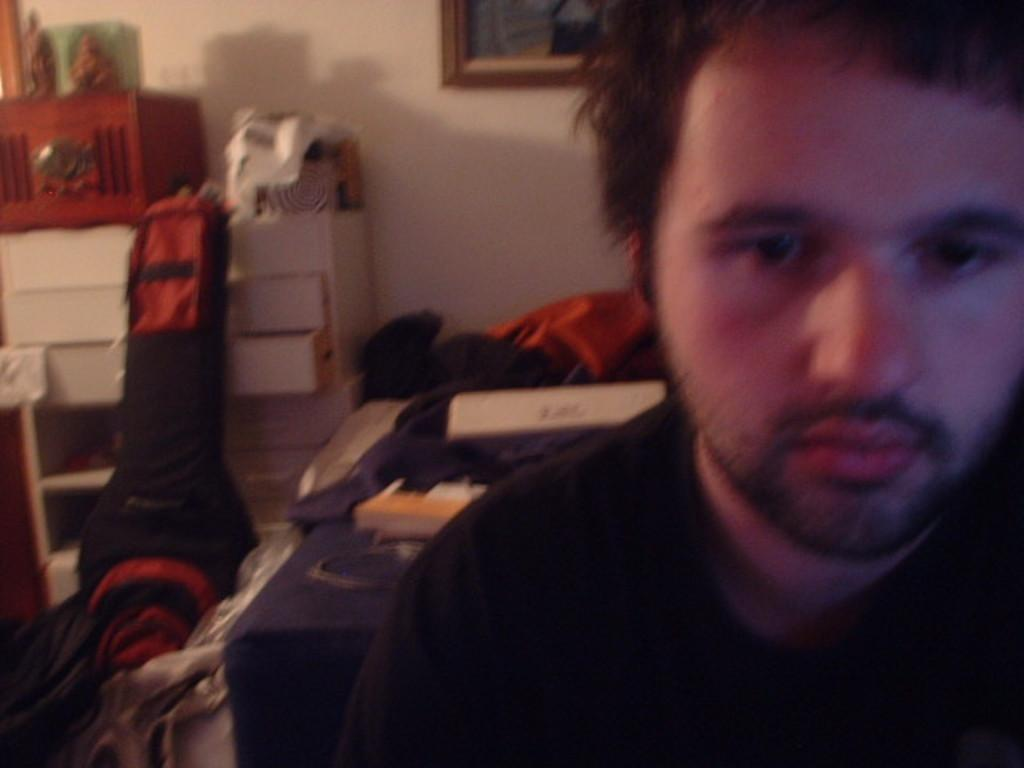Who is present in the image? There is a man in the image. What item related to musical instruments can be seen in the image? There is a guitar bag in the image. What type of personal belongings are visible in the image? There are clothes visible in the image. What type of furniture is present in the image? There is a cupboard with drawers in the image. What type of decorative objects are present in the image? There are statues in the image. What type of bag is present in the image? There is a carry bag in the image. What word does the man start saying in the image? There is no indication in the image of the man saying any words, so it cannot be determined from the image. 